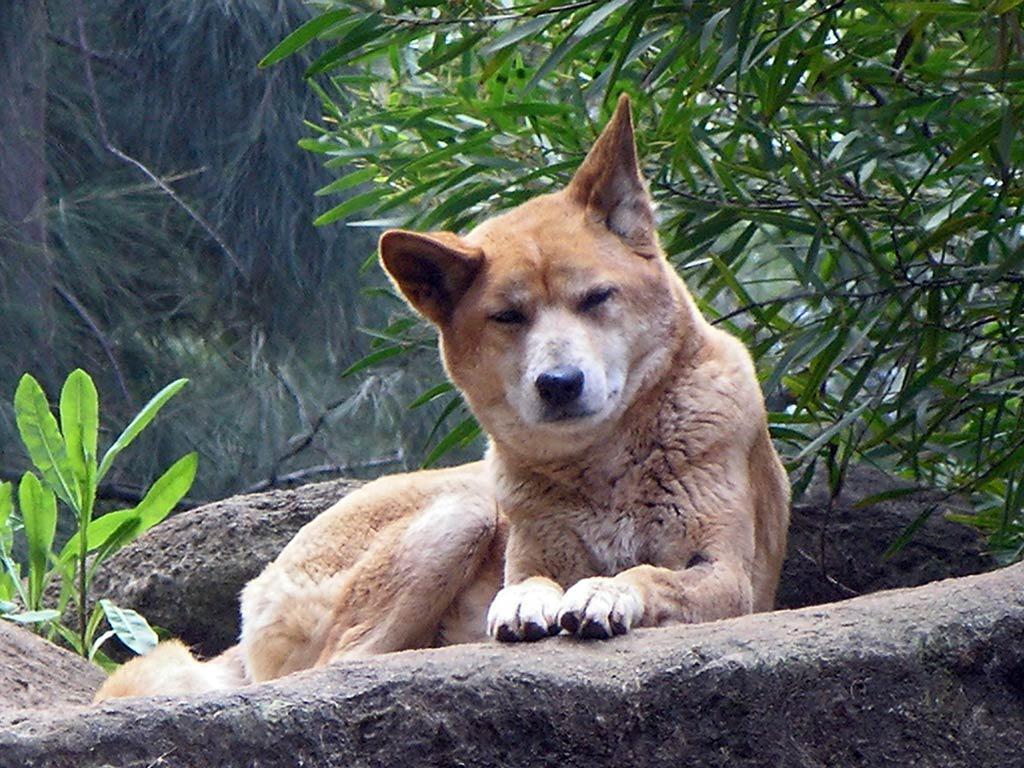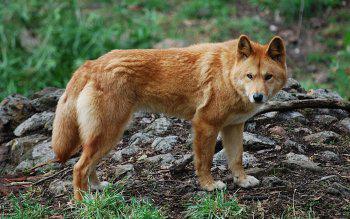The first image is the image on the left, the second image is the image on the right. Given the left and right images, does the statement "the animal in the image on the left is lying down" hold true? Answer yes or no. Yes. The first image is the image on the left, the second image is the image on the right. Given the left and right images, does the statement "1 dingo is standing on all fours." hold true? Answer yes or no. Yes. 